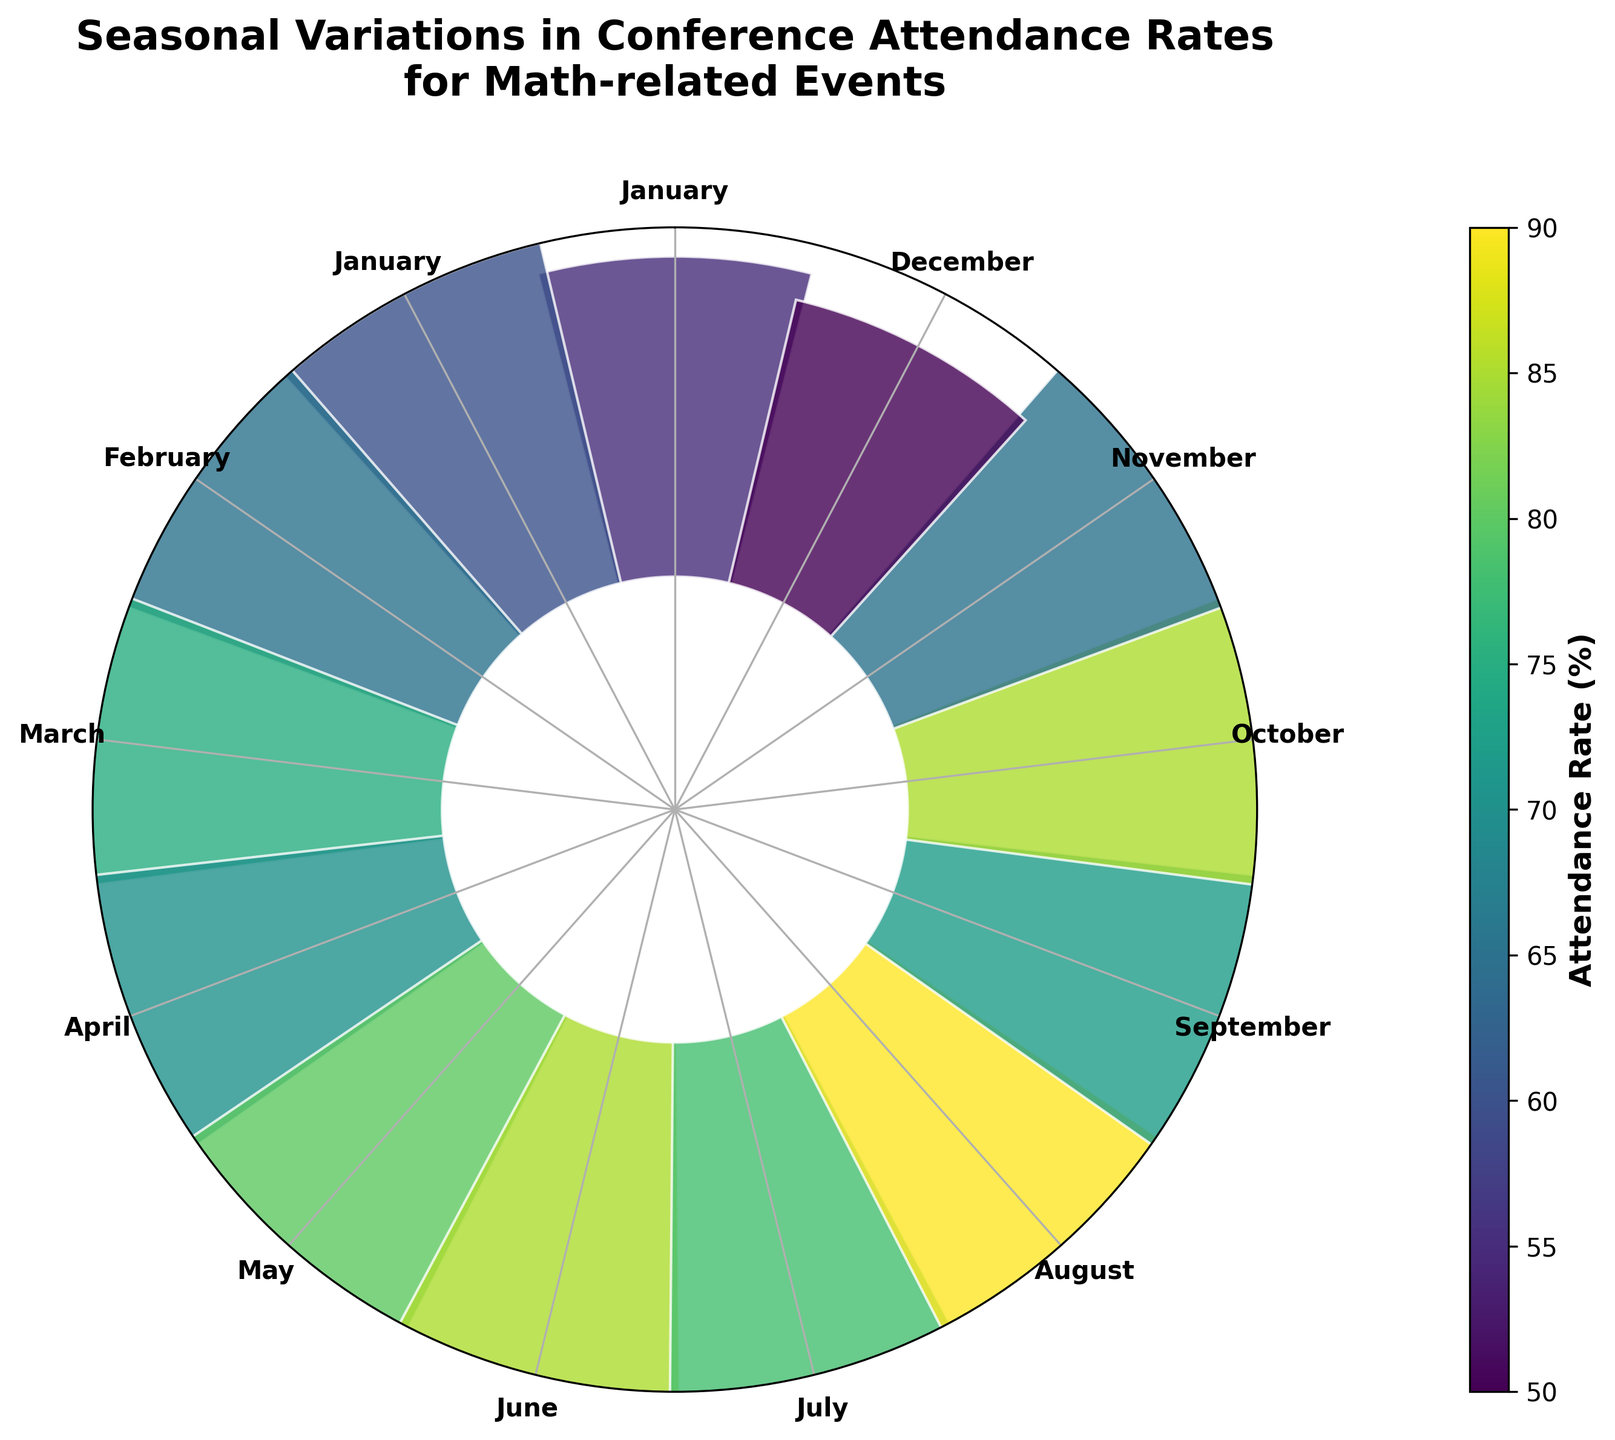Which month has the highest attendance rate? The largest bar in the plot corresponds to August, where the "International Conference on Harmonic Analysis and Partial Differential Equations" took place. This bar is the tallest, indicating the highest attendance rate.
Answer: August Which month has the lowest attendance rate? The smallest bar in the plot is for December, where the "American Mathematical Society Fall Eastern Sectional Meeting" took place. This bar is the shortest, indicating the lowest attendance rate.
Answer: December What is the attendance rate in March? Locate the bar corresponding to March on the plot, where the "Joint Mathematics Meetings" took place. The height of this bar represents the attendance rate, which is 75%.
Answer: 75% What is the title of the plot? The title of the plot is displayed at the top center of the figure. It reads "Seasonal Variations in Conference Attendance Rates\nfor Math-related Events."
Answer: Seasonal Variations in Conference Attendance Rates for Math-related Events What's the average attendance rate for the months June, July, and August? Identify the attendance rates for June (85%), July (78%), and August (90%). Add them up and divide by 3: (85 + 78 + 90) / 3 = 253 / 3 ≈ 84.33
Answer: 84.33 How does the attendance rate in May compare to November? Locate the bars for May (80%) and November (65%). The bar for May is higher, indicating that the attendance rate in May is greater than in November.
Answer: May attendance rate is higher How many months have an attendance rate greater than 70%? Identify the bars with attendance rates above 70%. The months are March, April, May, June, July, August, September, and October—8 months in total.
Answer: 8 Which months have an attendance rate equal to 85%? Locate the bars with a height of 85%. The months given by the plot are June for the "European Mathematical Society Congress" and October for the "Mathematical Association of America MathFest."
Answer: June and October What is the approximate range of attendance rates shown in the plot? Identify the highest and lowest attendance rates. The highest is 90% (August) and the lowest is 50% (December). The range is 90 - 50 = 40%.
Answer: 40% How are the bars colored in the plot? The bars are colored using a color map that varies according to their height, with a gradient of colors representing different attendance rates.
Answer: Colored by height with a gradient 